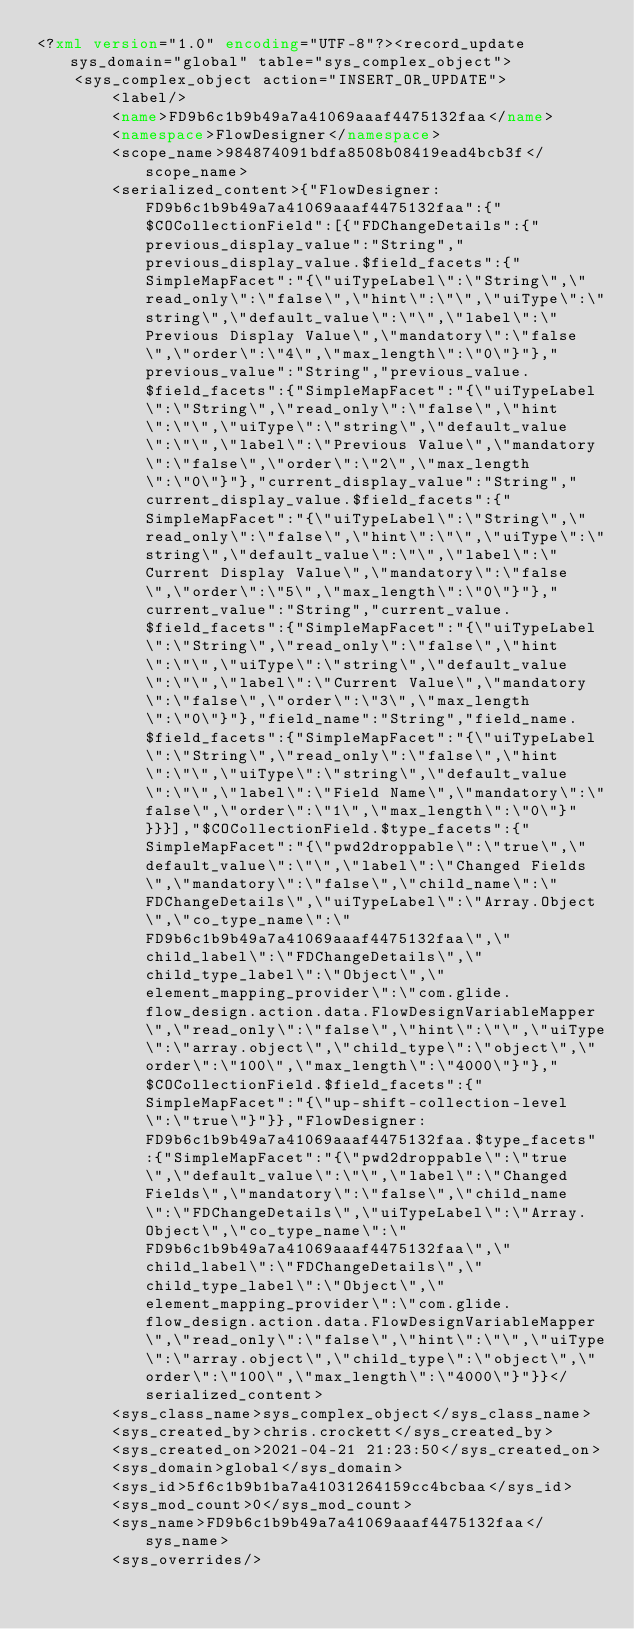<code> <loc_0><loc_0><loc_500><loc_500><_XML_><?xml version="1.0" encoding="UTF-8"?><record_update sys_domain="global" table="sys_complex_object">
    <sys_complex_object action="INSERT_OR_UPDATE">
        <label/>
        <name>FD9b6c1b9b49a7a41069aaaf4475132faa</name>
        <namespace>FlowDesigner</namespace>
        <scope_name>984874091bdfa8508b08419ead4bcb3f</scope_name>
        <serialized_content>{"FlowDesigner:FD9b6c1b9b49a7a41069aaaf4475132faa":{"$COCollectionField":[{"FDChangeDetails":{"previous_display_value":"String","previous_display_value.$field_facets":{"SimpleMapFacet":"{\"uiTypeLabel\":\"String\",\"read_only\":\"false\",\"hint\":\"\",\"uiType\":\"string\",\"default_value\":\"\",\"label\":\"Previous Display Value\",\"mandatory\":\"false\",\"order\":\"4\",\"max_length\":\"0\"}"},"previous_value":"String","previous_value.$field_facets":{"SimpleMapFacet":"{\"uiTypeLabel\":\"String\",\"read_only\":\"false\",\"hint\":\"\",\"uiType\":\"string\",\"default_value\":\"\",\"label\":\"Previous Value\",\"mandatory\":\"false\",\"order\":\"2\",\"max_length\":\"0\"}"},"current_display_value":"String","current_display_value.$field_facets":{"SimpleMapFacet":"{\"uiTypeLabel\":\"String\",\"read_only\":\"false\",\"hint\":\"\",\"uiType\":\"string\",\"default_value\":\"\",\"label\":\"Current Display Value\",\"mandatory\":\"false\",\"order\":\"5\",\"max_length\":\"0\"}"},"current_value":"String","current_value.$field_facets":{"SimpleMapFacet":"{\"uiTypeLabel\":\"String\",\"read_only\":\"false\",\"hint\":\"\",\"uiType\":\"string\",\"default_value\":\"\",\"label\":\"Current Value\",\"mandatory\":\"false\",\"order\":\"3\",\"max_length\":\"0\"}"},"field_name":"String","field_name.$field_facets":{"SimpleMapFacet":"{\"uiTypeLabel\":\"String\",\"read_only\":\"false\",\"hint\":\"\",\"uiType\":\"string\",\"default_value\":\"\",\"label\":\"Field Name\",\"mandatory\":\"false\",\"order\":\"1\",\"max_length\":\"0\"}"}}}],"$COCollectionField.$type_facets":{"SimpleMapFacet":"{\"pwd2droppable\":\"true\",\"default_value\":\"\",\"label\":\"Changed Fields\",\"mandatory\":\"false\",\"child_name\":\"FDChangeDetails\",\"uiTypeLabel\":\"Array.Object\",\"co_type_name\":\"FD9b6c1b9b49a7a41069aaaf4475132faa\",\"child_label\":\"FDChangeDetails\",\"child_type_label\":\"Object\",\"element_mapping_provider\":\"com.glide.flow_design.action.data.FlowDesignVariableMapper\",\"read_only\":\"false\",\"hint\":\"\",\"uiType\":\"array.object\",\"child_type\":\"object\",\"order\":\"100\",\"max_length\":\"4000\"}"},"$COCollectionField.$field_facets":{"SimpleMapFacet":"{\"up-shift-collection-level\":\"true\"}"}},"FlowDesigner:FD9b6c1b9b49a7a41069aaaf4475132faa.$type_facets":{"SimpleMapFacet":"{\"pwd2droppable\":\"true\",\"default_value\":\"\",\"label\":\"Changed Fields\",\"mandatory\":\"false\",\"child_name\":\"FDChangeDetails\",\"uiTypeLabel\":\"Array.Object\",\"co_type_name\":\"FD9b6c1b9b49a7a41069aaaf4475132faa\",\"child_label\":\"FDChangeDetails\",\"child_type_label\":\"Object\",\"element_mapping_provider\":\"com.glide.flow_design.action.data.FlowDesignVariableMapper\",\"read_only\":\"false\",\"hint\":\"\",\"uiType\":\"array.object\",\"child_type\":\"object\",\"order\":\"100\",\"max_length\":\"4000\"}"}}</serialized_content>
        <sys_class_name>sys_complex_object</sys_class_name>
        <sys_created_by>chris.crockett</sys_created_by>
        <sys_created_on>2021-04-21 21:23:50</sys_created_on>
        <sys_domain>global</sys_domain>
        <sys_id>5f6c1b9b1ba7a41031264159cc4bcbaa</sys_id>
        <sys_mod_count>0</sys_mod_count>
        <sys_name>FD9b6c1b9b49a7a41069aaaf4475132faa</sys_name>
        <sys_overrides/></code> 